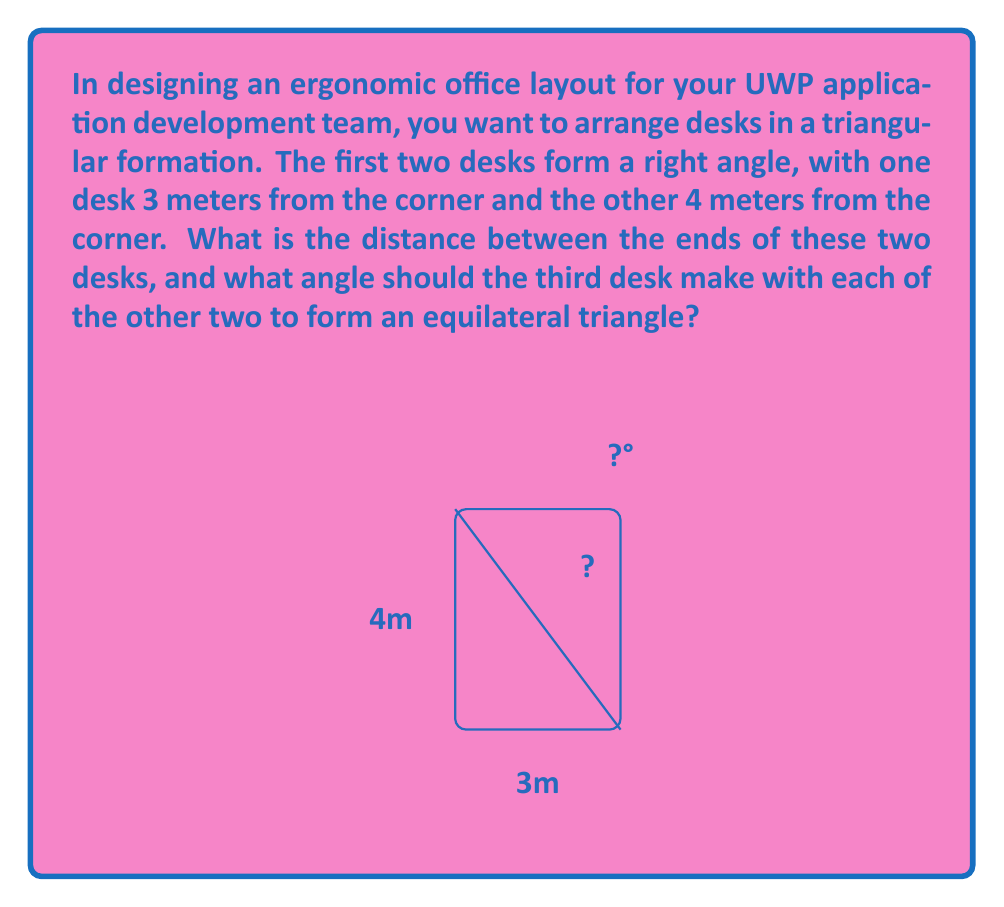Solve this math problem. Let's approach this problem step by step:

1) First, let's find the distance between the ends of the two desks. This forms the hypotenuse of a right-angled triangle with sides 3m and 4m. We can use the Pythagorean theorem:

   $$a^2 + b^2 = c^2$$
   $$3^2 + 4^2 = c^2$$
   $$9 + 16 = c^2$$
   $$25 = c^2$$
   $$c = 5$$

   So, the distance between the ends of the desks is 5 meters.

2) Now, for the second part of the question, we need to find the angle that would make this an equilateral triangle. In an equilateral triangle, all sides are equal and all angles are 60°.

3) The angle we're looking for is the supplement of the right angle (90°) in our current triangle. Let's call this angle $\theta$:

   $$\theta + 90° = 60°$$
   $$\theta = 60° - 90° = -30°$$

4) The negative sign just indicates that we need to decrease the 90° angle by 30°. So, each of the other two angles of our triangle should be 30°.

5) To verify:
   $$90° - 30° = 60°$$
   $$30° + 30° + 60° = 120°$$

   This indeed forms an equilateral triangle, as the sum of angles in a triangle is always 180°.
Answer: 5 meters; 30° 